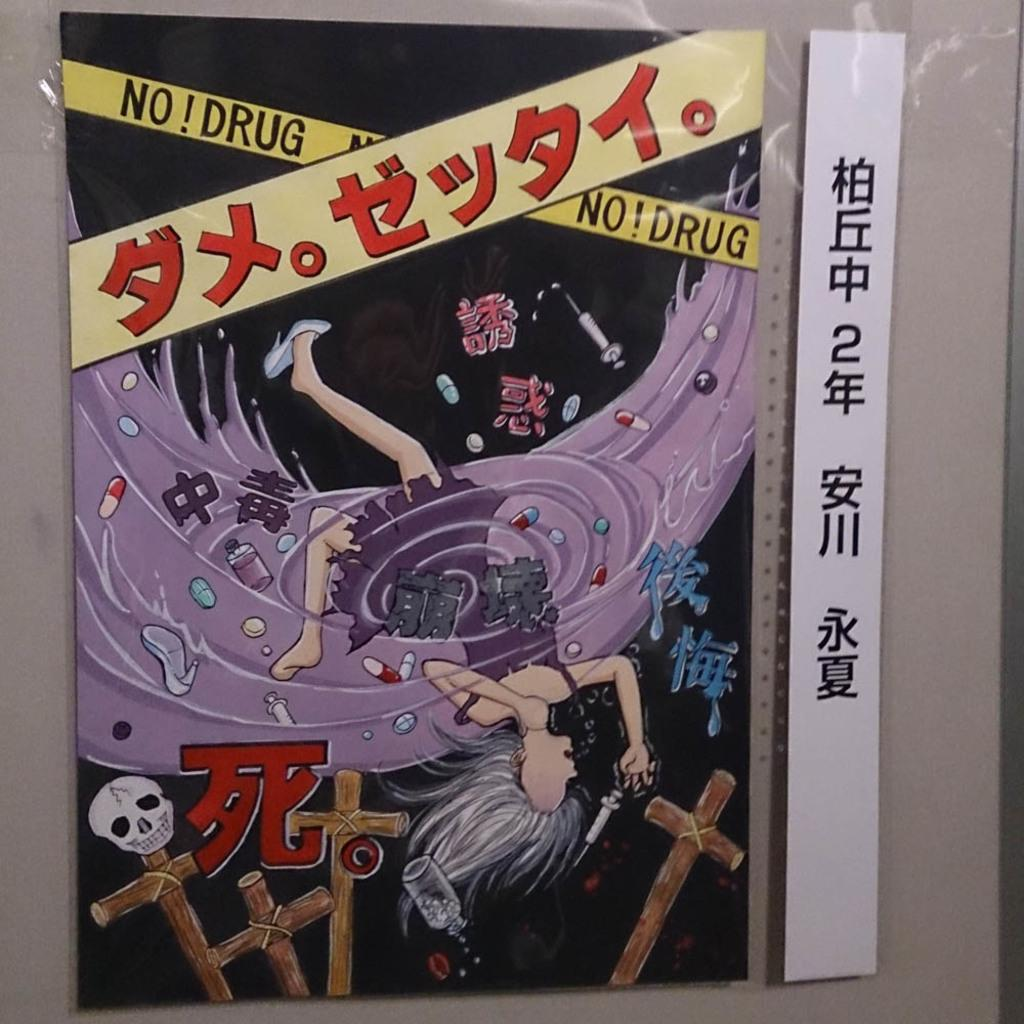Provide a one-sentence caption for the provided image. A poster of a girl in a tsunami with some foreign promoting NO! Drug. 